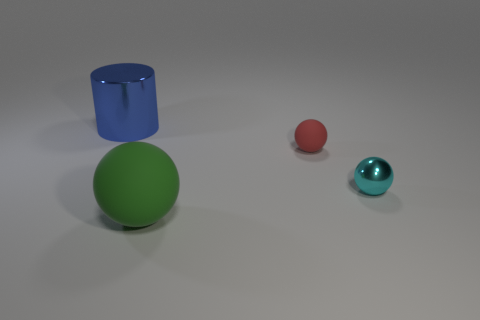Compare the sizes of the objects. The green sphere is the largest object in the scene, followed by the blue cylinder which has a smaller diameter but similar height. The red sphere is the smallest object, significantly tinier than the green sphere and the blue cylinder. 